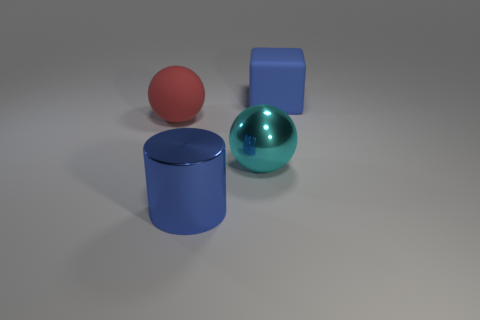Subtract 1 spheres. How many spheres are left? 1 Subtract all cubes. How many objects are left? 3 Subtract all large green shiny balls. Subtract all big red matte spheres. How many objects are left? 3 Add 4 large objects. How many large objects are left? 8 Add 3 rubber balls. How many rubber balls exist? 4 Add 2 big blue rubber cubes. How many objects exist? 6 Subtract 0 yellow spheres. How many objects are left? 4 Subtract all red spheres. Subtract all green blocks. How many spheres are left? 1 Subtract all blue cylinders. How many yellow balls are left? 0 